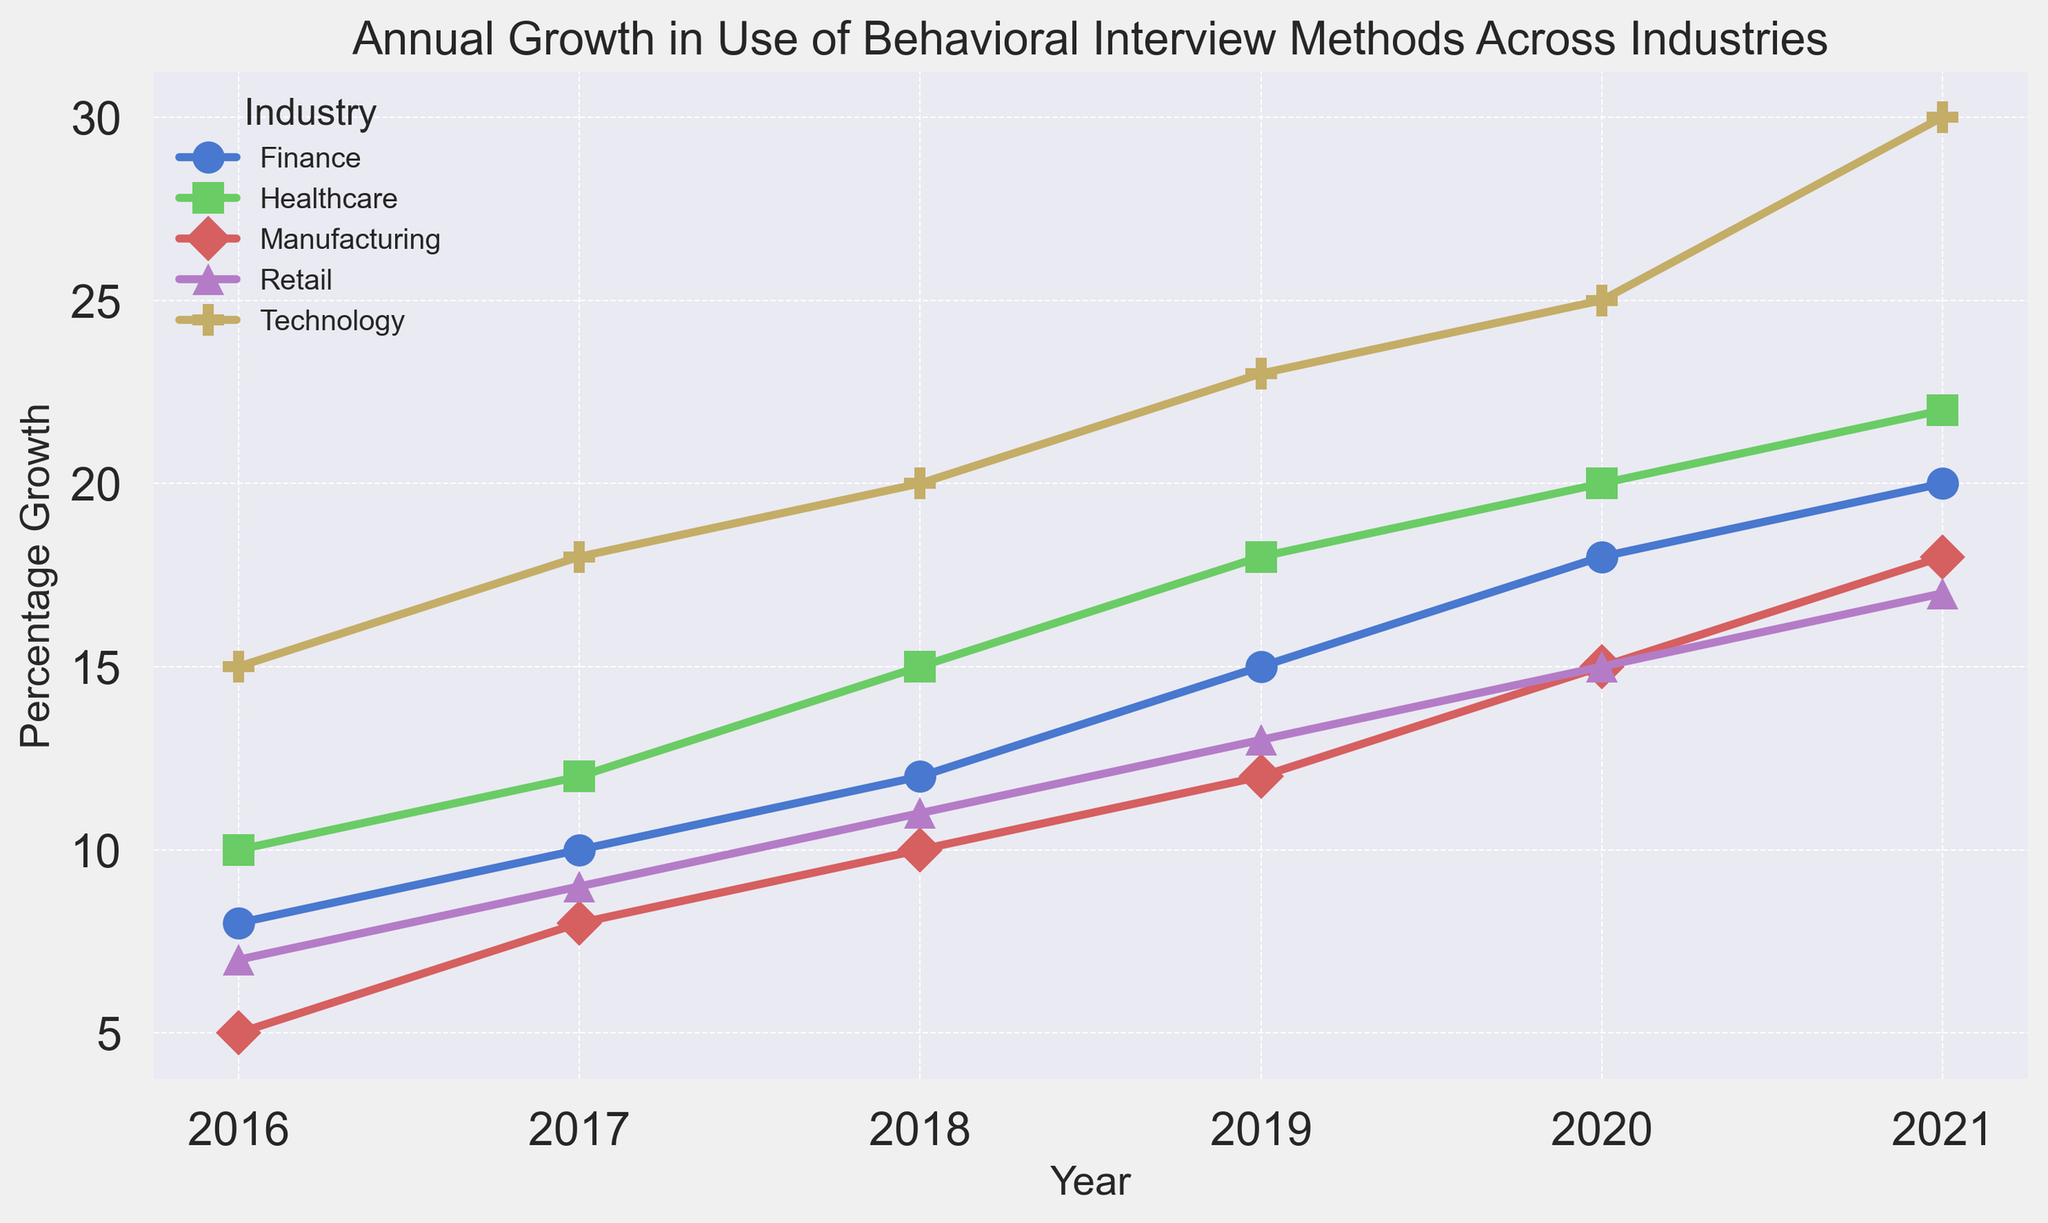What was the percentage growth in the use of behavioral interview methods for the Technology industry in 2016? Locate the point for the Technology industry in 2016 on the x-axis and read the corresponding y-axis value.
Answer: 15 Which industry experienced the highest percentage growth in 2021? Identify the line that reaches the highest point in 2021 and refer to the legend to determine the corresponding industry.
Answer: Technology Between 2019 and 2021, which industry saw the largest increase in percentage growth? Compare the difference in percentage growth for each industry from 2019 to 2021 and find the largest difference.
Answer: Technology By how much did the percentage growth in the use of behavioral interview methods for the Healthcare industry increase from 2018 to 2020? Subtract the percentage growth in 2018 from the percentage growth in 2020 for Healthcare: 20 - 15.
Answer: 5 In which year did the Retail industry see an equal level of percentage growth as the Healthcare industry saw in 2017? Identify the percentage growth for Healthcare in 2017 (12) and find the year in which the Retail industry had the same value. Retail had the same 12 in 2018.
Answer: 2018 What is the average percentage growth for the Finance industry over the years 2016 to 2018? Sum the growth percentages for 2016, 2017, and 2018, then divide by 3: (8 + 10 + 12) / 3.
Answer: 10 Which industry had the lowest percentage growth in 2016, and what was the value? Locate the lowest point on the chart for 2016 and refer to the legend. The lowest value is for Manufacturing and is 5.
Answer: Manufacturing, 5 Compare the percentage growth trends for the Technology and Manufacturing industries from 2016 to 2021. Which industry shows a steeper overall upward trend? Observe the slope of the lines for Technology and Manufacturing and determine which one has a sharper increase from 2016 to 2021.
Answer: Technology What was the cumulative percentage growth for the Retail industry from 2016 to 2021? Sum the annual percentage growth values for Retail from 2016 to 2021: 7 + 9 + 11 + 13 + 15 + 17.
Answer: 72 Which industries showed consistent growth over all the plotted years? Identify lines that show a continuous upward trend without any dips between 2016 and 2021. The valid industries show upward slopes throughout all these years.
Answer: All industries 